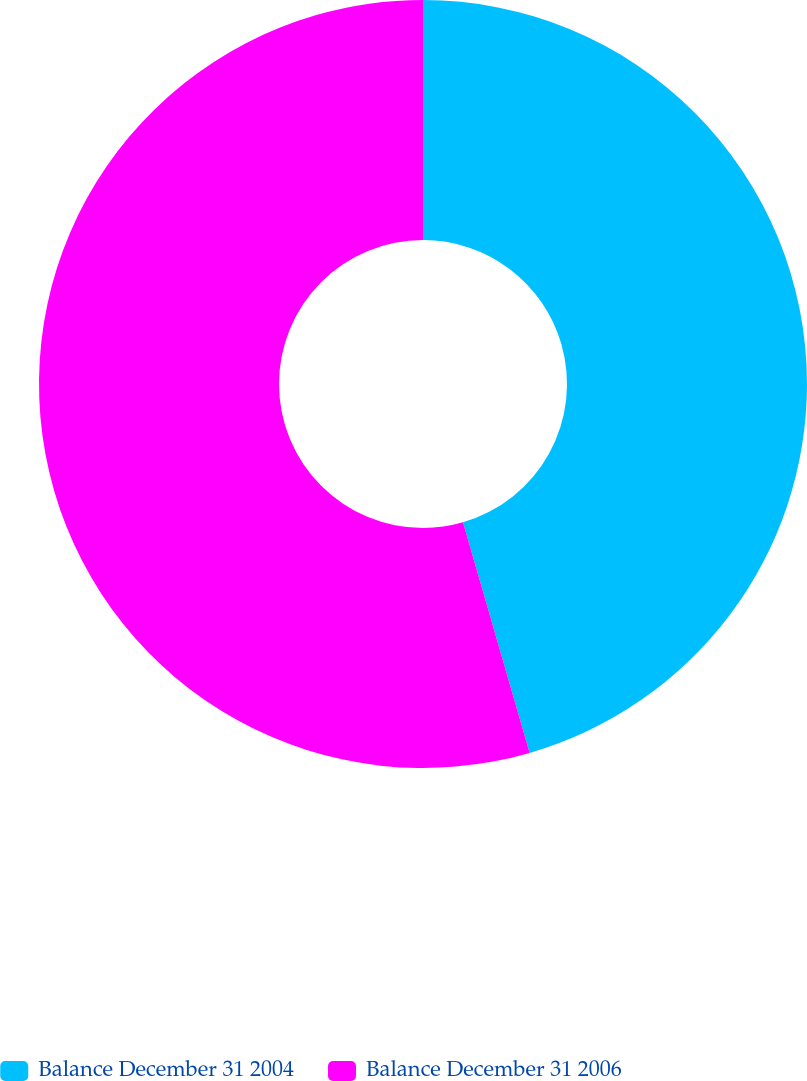Convert chart to OTSL. <chart><loc_0><loc_0><loc_500><loc_500><pie_chart><fcel>Balance December 31 2004<fcel>Balance December 31 2006<nl><fcel>45.52%<fcel>54.48%<nl></chart> 